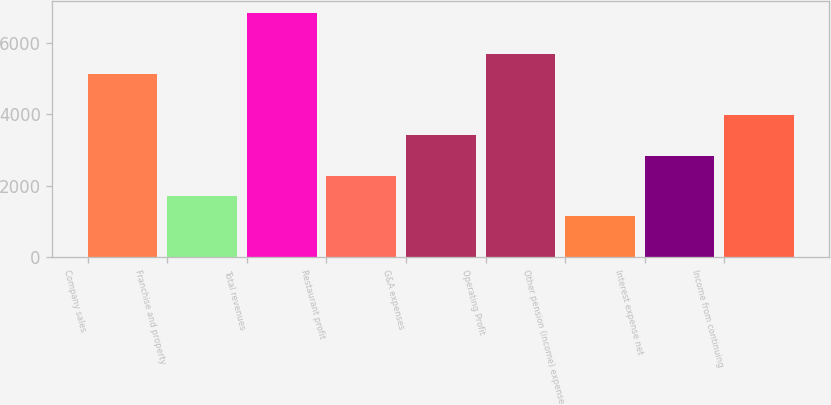Convert chart. <chart><loc_0><loc_0><loc_500><loc_500><bar_chart><fcel>Company sales<fcel>Franchise and property<fcel>Total revenues<fcel>Restaurant profit<fcel>G&A expenses<fcel>Operating Profit<fcel>Other pension (income) expense<fcel>Interest expense net<fcel>Income from continuing<nl><fcel>5119.66<fcel>1709.68<fcel>6824.65<fcel>2278.01<fcel>3414.67<fcel>5687.99<fcel>1141.35<fcel>2846.34<fcel>3983<nl></chart> 